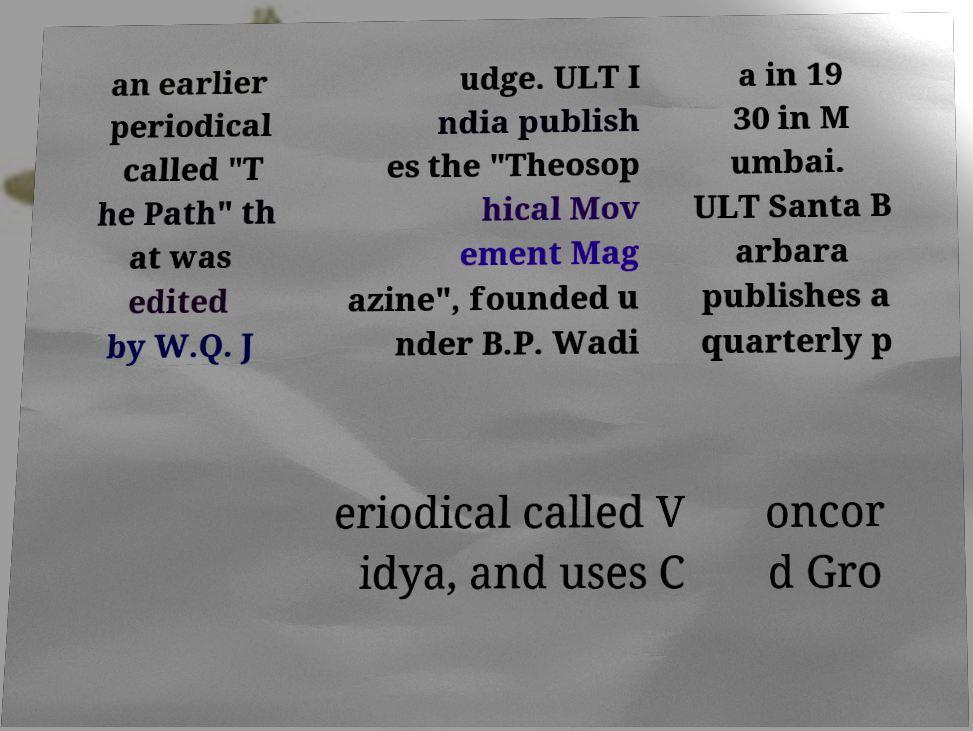What messages or text are displayed in this image? I need them in a readable, typed format. an earlier periodical called "T he Path" th at was edited by W.Q. J udge. ULT I ndia publish es the "Theosop hical Mov ement Mag azine", founded u nder B.P. Wadi a in 19 30 in M umbai. ULT Santa B arbara publishes a quarterly p eriodical called V idya, and uses C oncor d Gro 